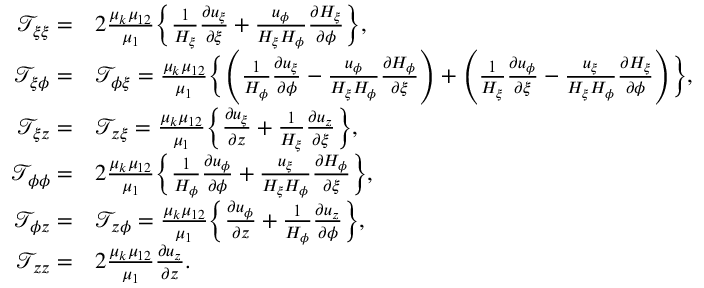<formula> <loc_0><loc_0><loc_500><loc_500>\begin{array} { r l } { \mathcal { T } _ { \xi \xi } = } & { 2 \frac { \mu _ { k } \mu _ { 1 2 } } { \mu _ { 1 } } \left \{ \frac { 1 } { H _ { \xi } } \frac { \partial u _ { \xi } } { \partial \xi } + \frac { u _ { \phi } } { H _ { \xi } H _ { \phi } } \frac { \partial H _ { \xi } } { \partial \phi } \right \} , } \\ { \mathcal { T } _ { \xi \phi } = } & { \mathcal { T } _ { \phi \xi } = \frac { \mu _ { k } \mu _ { 1 2 } } { \mu _ { 1 } } \left \{ \left ( \frac { 1 } { H _ { \phi } } \frac { \partial u _ { \xi } } { \partial \phi } - \frac { u _ { \phi } } { H _ { \xi } H _ { \phi } } \frac { \partial H _ { \phi } } { \partial \xi } \right ) + \left ( \frac { 1 } { H _ { \xi } } \frac { \partial u _ { \phi } } { \partial \xi } - \frac { u _ { \xi } } { H _ { \xi } H _ { \phi } } \frac { \partial H _ { \xi } } { \partial \phi } \right ) \right \} , } \\ { \mathcal { T } _ { \xi z } = } & { \mathcal { T } _ { z \xi } = \frac { \mu _ { k } \mu _ { 1 2 } } { \mu _ { 1 } } \left \{ \frac { \partial u _ { \xi } } { \partial z } + \frac { 1 } { H _ { \xi } } \frac { \partial u _ { z } } { \partial \xi } \right \} , } \\ { \mathcal { T } _ { \phi \phi } = } & { 2 \frac { \mu _ { k } \mu _ { 1 2 } } { \mu _ { 1 } } \left \{ \frac { 1 } { H _ { \phi } } \frac { \partial u _ { \phi } } { \partial \phi } + \frac { u _ { \xi } } { H _ { \xi } H _ { \phi } } \frac { \partial H _ { \phi } } { \partial \xi } \right \} , } \\ { \mathcal { T } _ { \phi z } = } & { \mathcal { T } _ { z \phi } = \frac { \mu _ { k } \mu _ { 1 2 } } { \mu _ { 1 } } \left \{ \frac { \partial u _ { \phi } } { \partial z } + \frac { 1 } { H _ { \phi } } \frac { \partial u _ { z } } { \partial \phi } \right \} , } \\ { \mathcal { T } _ { z z } = } & { 2 \frac { \mu _ { k } \mu _ { 1 2 } } { \mu _ { 1 } } \frac { \partial u _ { z } } { \partial z } . } \end{array}</formula> 